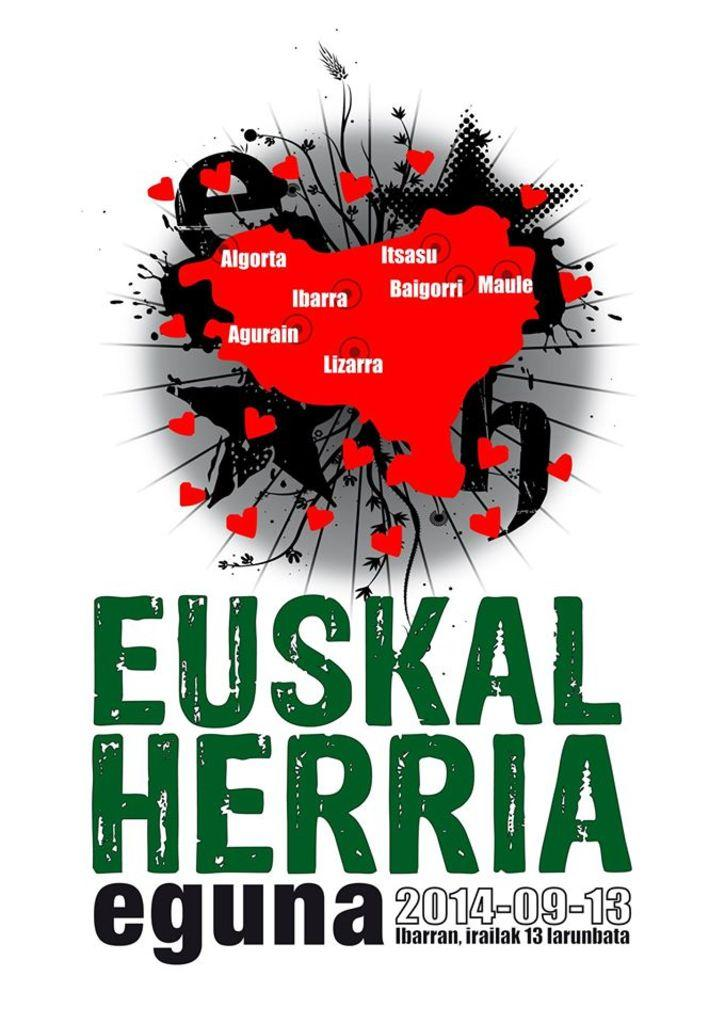Provide a one-sentence caption for the provided image. A poster for an event called Euskal Herria Eguna with the date 2014-09-13. 